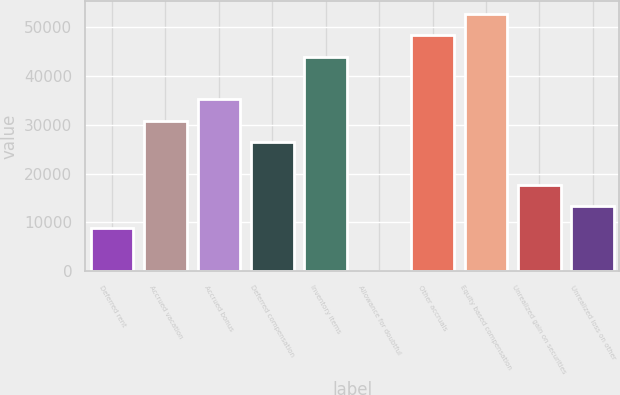Convert chart. <chart><loc_0><loc_0><loc_500><loc_500><bar_chart><fcel>Deferred rent<fcel>Accrued vacation<fcel>Accrued bonus<fcel>Deferred compensation<fcel>Inventory items<fcel>Allowance for doubtful<fcel>Other accruals<fcel>Equity based compensation<fcel>Unrealized gain on securities<fcel>Unrealized loss on other<nl><fcel>8882.2<fcel>30792.7<fcel>35174.8<fcel>26410.6<fcel>43939<fcel>118<fcel>48321.1<fcel>52703.2<fcel>17646.4<fcel>13264.3<nl></chart> 